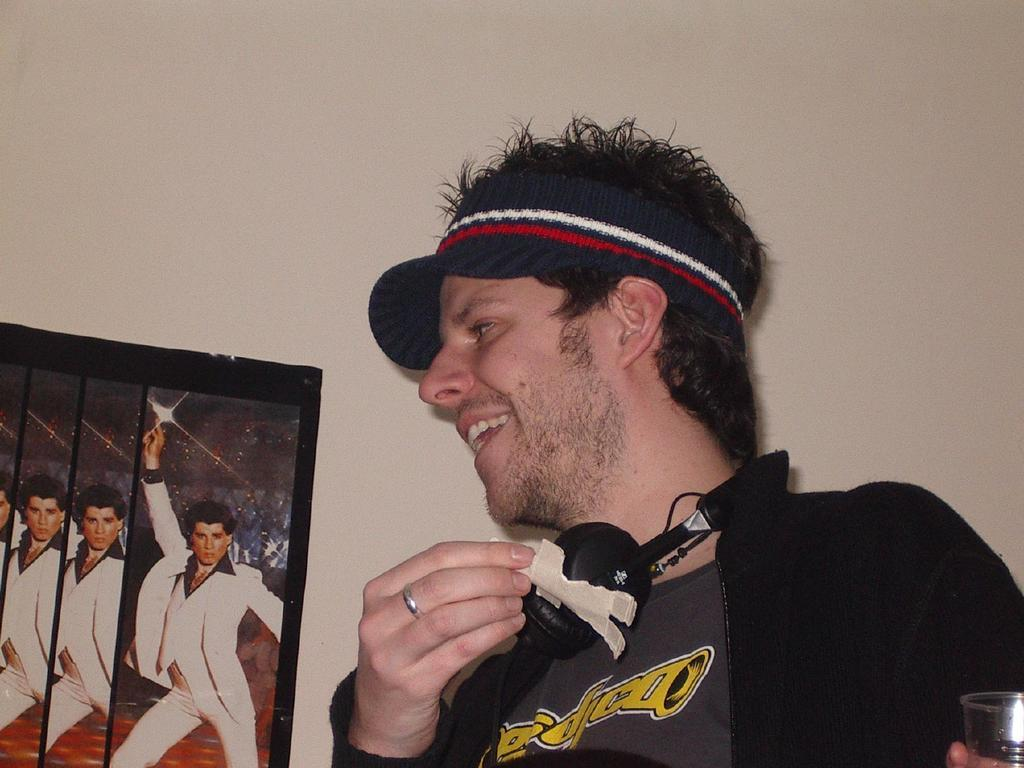What is the main subject of the image? The main subject of the image is a man. What is the man wearing on his head? The man is wearing a cap. What is the man wearing on his ears? The man is wearing headsets. What is the man holding in his hand? The man is holding an object and a glass. What can be seen on the wall in front of the man? There is a photo on the wall in front of the man. How many books can be seen on the man's hand in the image? There are no books visible on the man's hand in the image. 